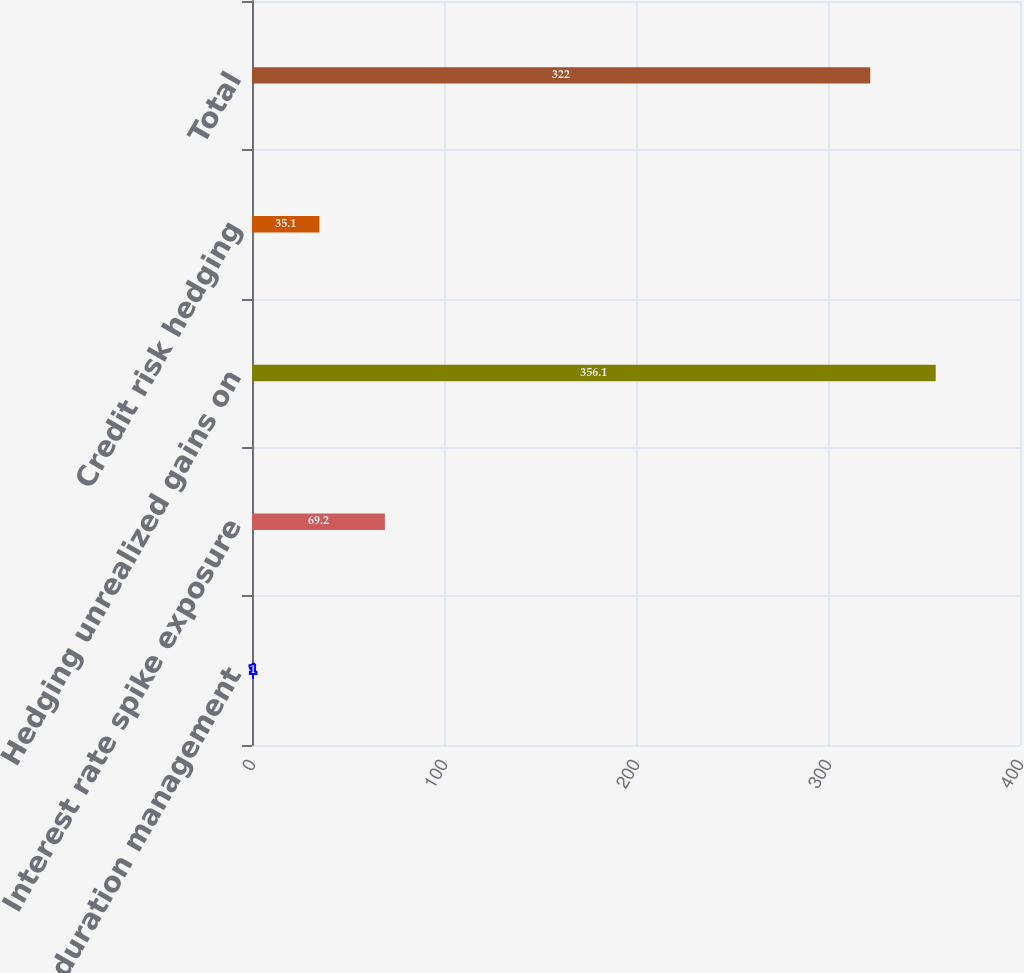<chart> <loc_0><loc_0><loc_500><loc_500><bar_chart><fcel>Portfolio duration management<fcel>Interest rate spike exposure<fcel>Hedging unrealized gains on<fcel>Credit risk hedging<fcel>Total<nl><fcel>1<fcel>69.2<fcel>356.1<fcel>35.1<fcel>322<nl></chart> 